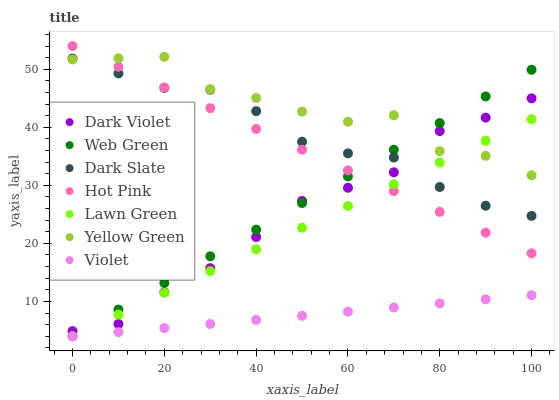Does Violet have the minimum area under the curve?
Answer yes or no. Yes. Does Yellow Green have the maximum area under the curve?
Answer yes or no. Yes. Does Hot Pink have the minimum area under the curve?
Answer yes or no. No. Does Hot Pink have the maximum area under the curve?
Answer yes or no. No. Is Violet the smoothest?
Answer yes or no. Yes. Is Yellow Green the roughest?
Answer yes or no. Yes. Is Hot Pink the smoothest?
Answer yes or no. No. Is Hot Pink the roughest?
Answer yes or no. No. Does Lawn Green have the lowest value?
Answer yes or no. Yes. Does Hot Pink have the lowest value?
Answer yes or no. No. Does Hot Pink have the highest value?
Answer yes or no. Yes. Does Yellow Green have the highest value?
Answer yes or no. No. Is Violet less than Yellow Green?
Answer yes or no. Yes. Is Hot Pink greater than Violet?
Answer yes or no. Yes. Does Web Green intersect Hot Pink?
Answer yes or no. Yes. Is Web Green less than Hot Pink?
Answer yes or no. No. Is Web Green greater than Hot Pink?
Answer yes or no. No. Does Violet intersect Yellow Green?
Answer yes or no. No. 